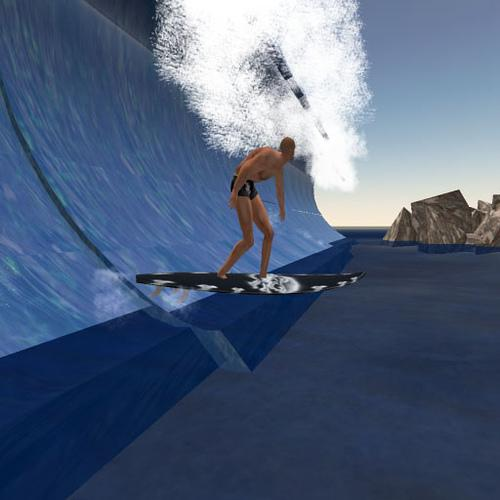Question: why is the man standing on a board?
Choices:
A. To surf.
B. To paint.
C. To dive.
D. To skateboard.
Answer with the letter. Answer: A Question: what is the man standing on?
Choices:
A. Bridge.
B. Boat.
C. Pier.
D. A surfboard.
Answer with the letter. Answer: D Question: what color are the rocks?
Choices:
A. Grey.
B. Black.
C. White.
D. Brown.
Answer with the letter. Answer: D Question: when did this occur?
Choices:
A. At night.
B. At noon.
C. During the day.
D. Yesterday.
Answer with the letter. Answer: C 